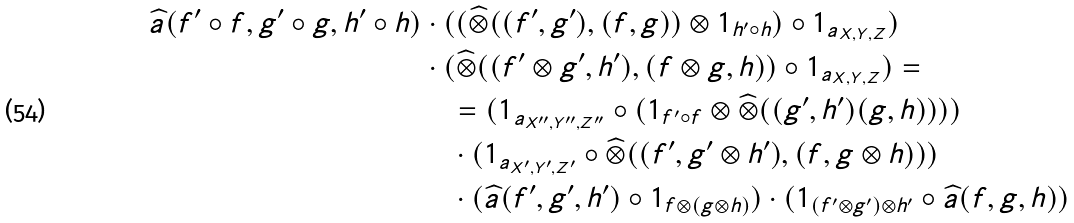Convert formula to latex. <formula><loc_0><loc_0><loc_500><loc_500>\widehat { a } ( f ^ { \prime } \circ f , g ^ { \prime } \circ g , h ^ { \prime } \circ h ) & \cdot ( ( \widehat { \otimes } ( ( f ^ { \prime } , g ^ { \prime } ) , ( f , g ) ) \otimes 1 _ { h ^ { \prime } \circ h } ) \circ 1 _ { a _ { X , Y , Z } } ) \\ & \cdot ( \widehat { \otimes } ( ( f ^ { \prime } \otimes g ^ { \prime } , h ^ { \prime } ) , ( f \otimes g , h ) ) \circ 1 _ { a _ { X , Y , Z } } ) = \\ & \quad = ( 1 _ { a _ { X ^ { \prime \prime } , Y ^ { \prime \prime } , Z ^ { \prime \prime } } } \circ ( 1 _ { f ^ { \prime } \circ f } \otimes \widehat { \otimes } ( ( g ^ { \prime } , h ^ { \prime } ) ( g , h ) ) ) ) \\ & \quad \cdot ( 1 _ { a _ { X ^ { \prime } , Y ^ { \prime } , Z ^ { \prime } } } \circ \widehat { \otimes } ( ( f ^ { \prime } , g ^ { \prime } \otimes h ^ { \prime } ) , ( f , g \otimes h ) ) ) \\ & \quad \cdot ( \widehat { a } ( f ^ { \prime } , g ^ { \prime } , h ^ { \prime } ) \circ 1 _ { f \otimes ( g \otimes h ) } ) \cdot ( 1 _ { ( f ^ { \prime } \otimes g ^ { \prime } ) \otimes h ^ { \prime } } \circ \widehat { a } ( f , g , h ) )</formula> 